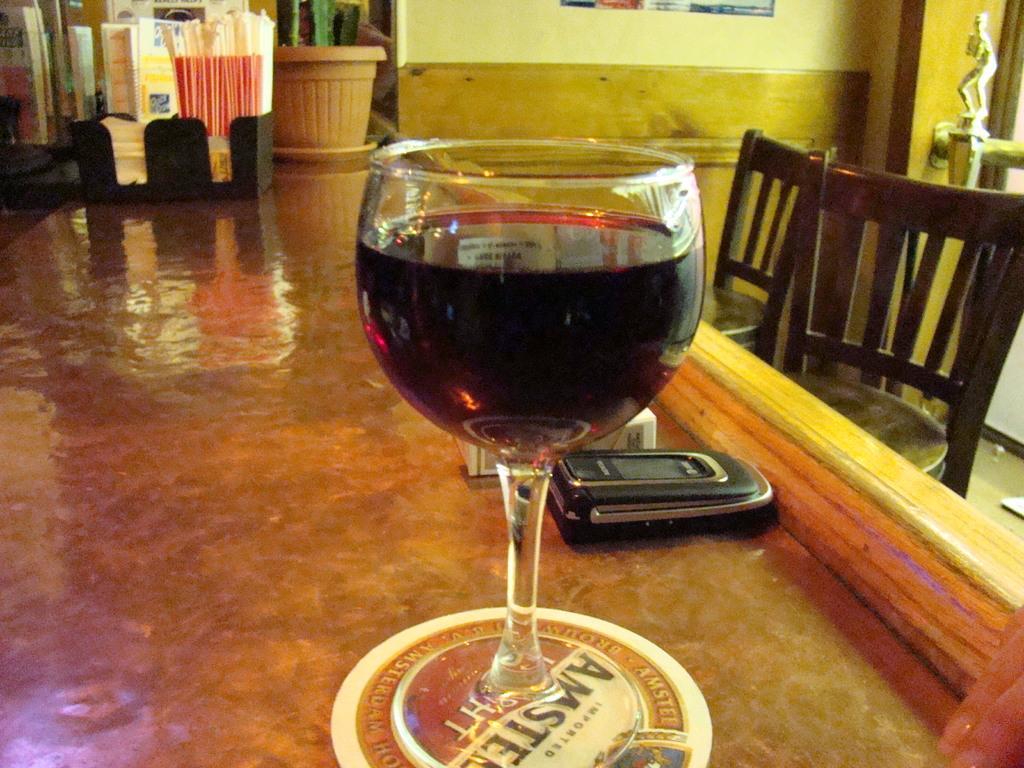Describe this image in one or two sentences. In this image, we can see a table contains a glass and phone. There are chairs on the right side of the image. There is a plant at the top of the image. 